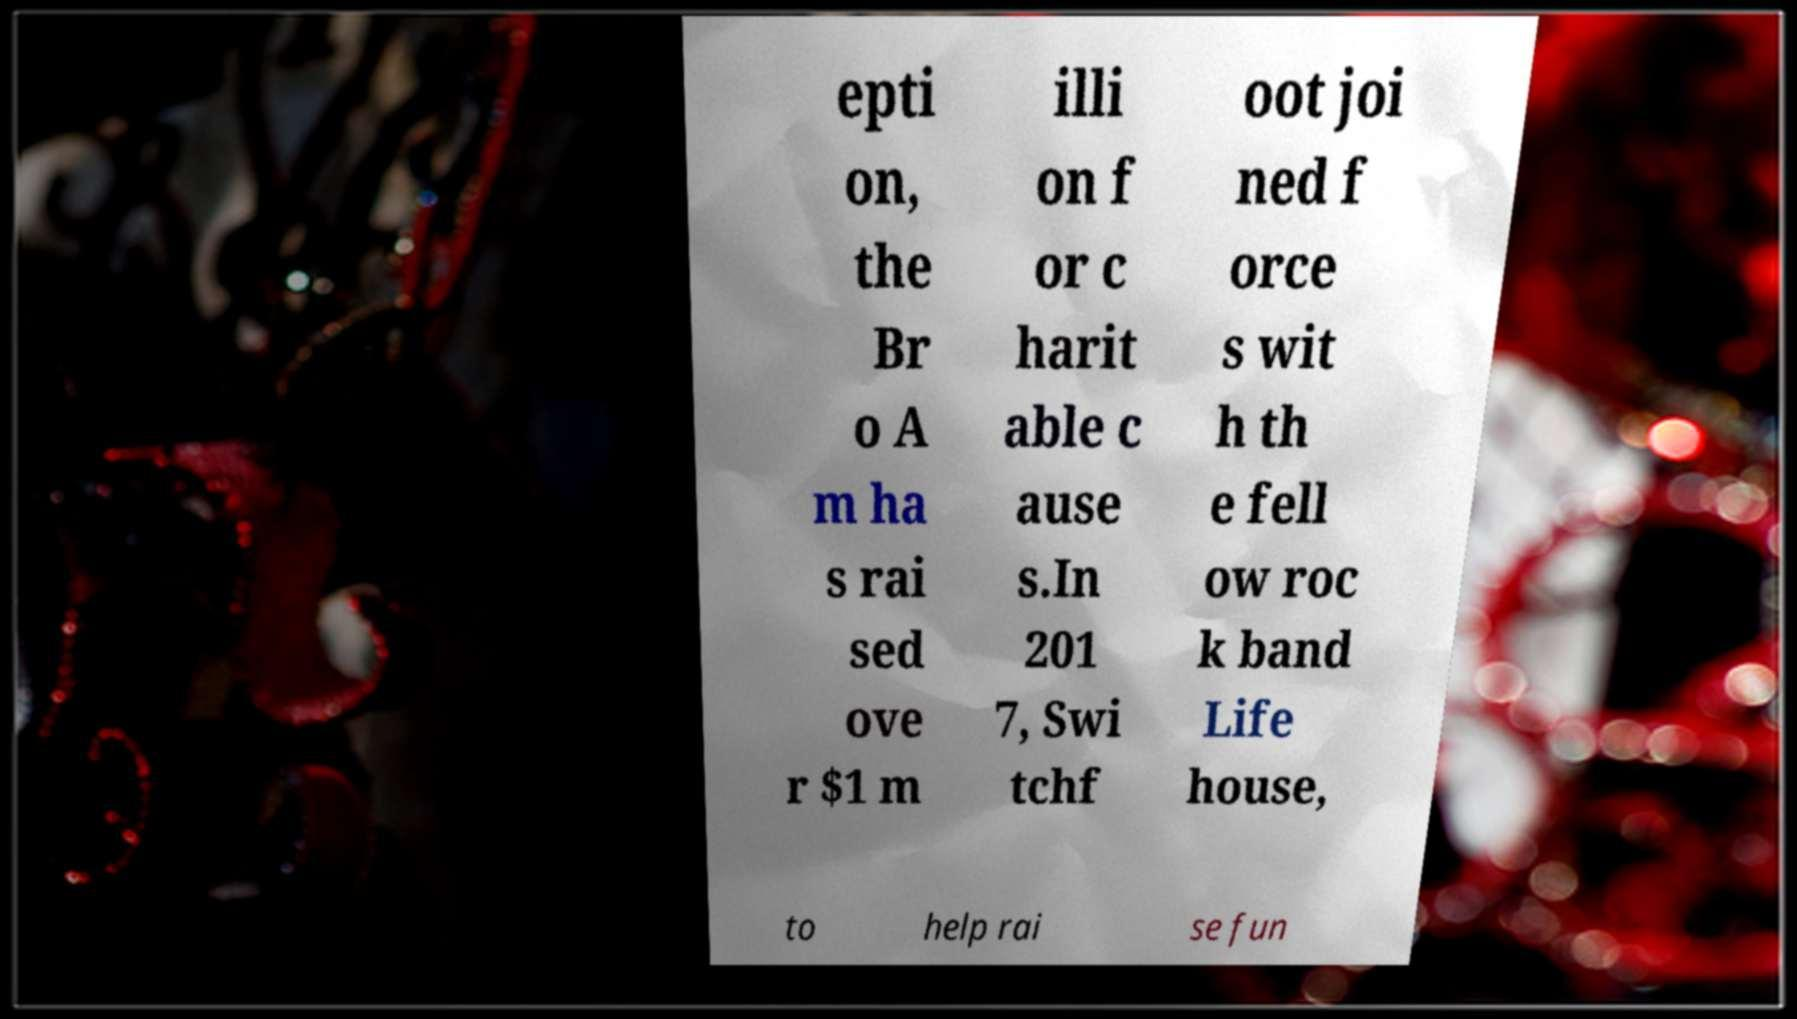Can you read and provide the text displayed in the image?This photo seems to have some interesting text. Can you extract and type it out for me? epti on, the Br o A m ha s rai sed ove r $1 m illi on f or c harit able c ause s.In 201 7, Swi tchf oot joi ned f orce s wit h th e fell ow roc k band Life house, to help rai se fun 